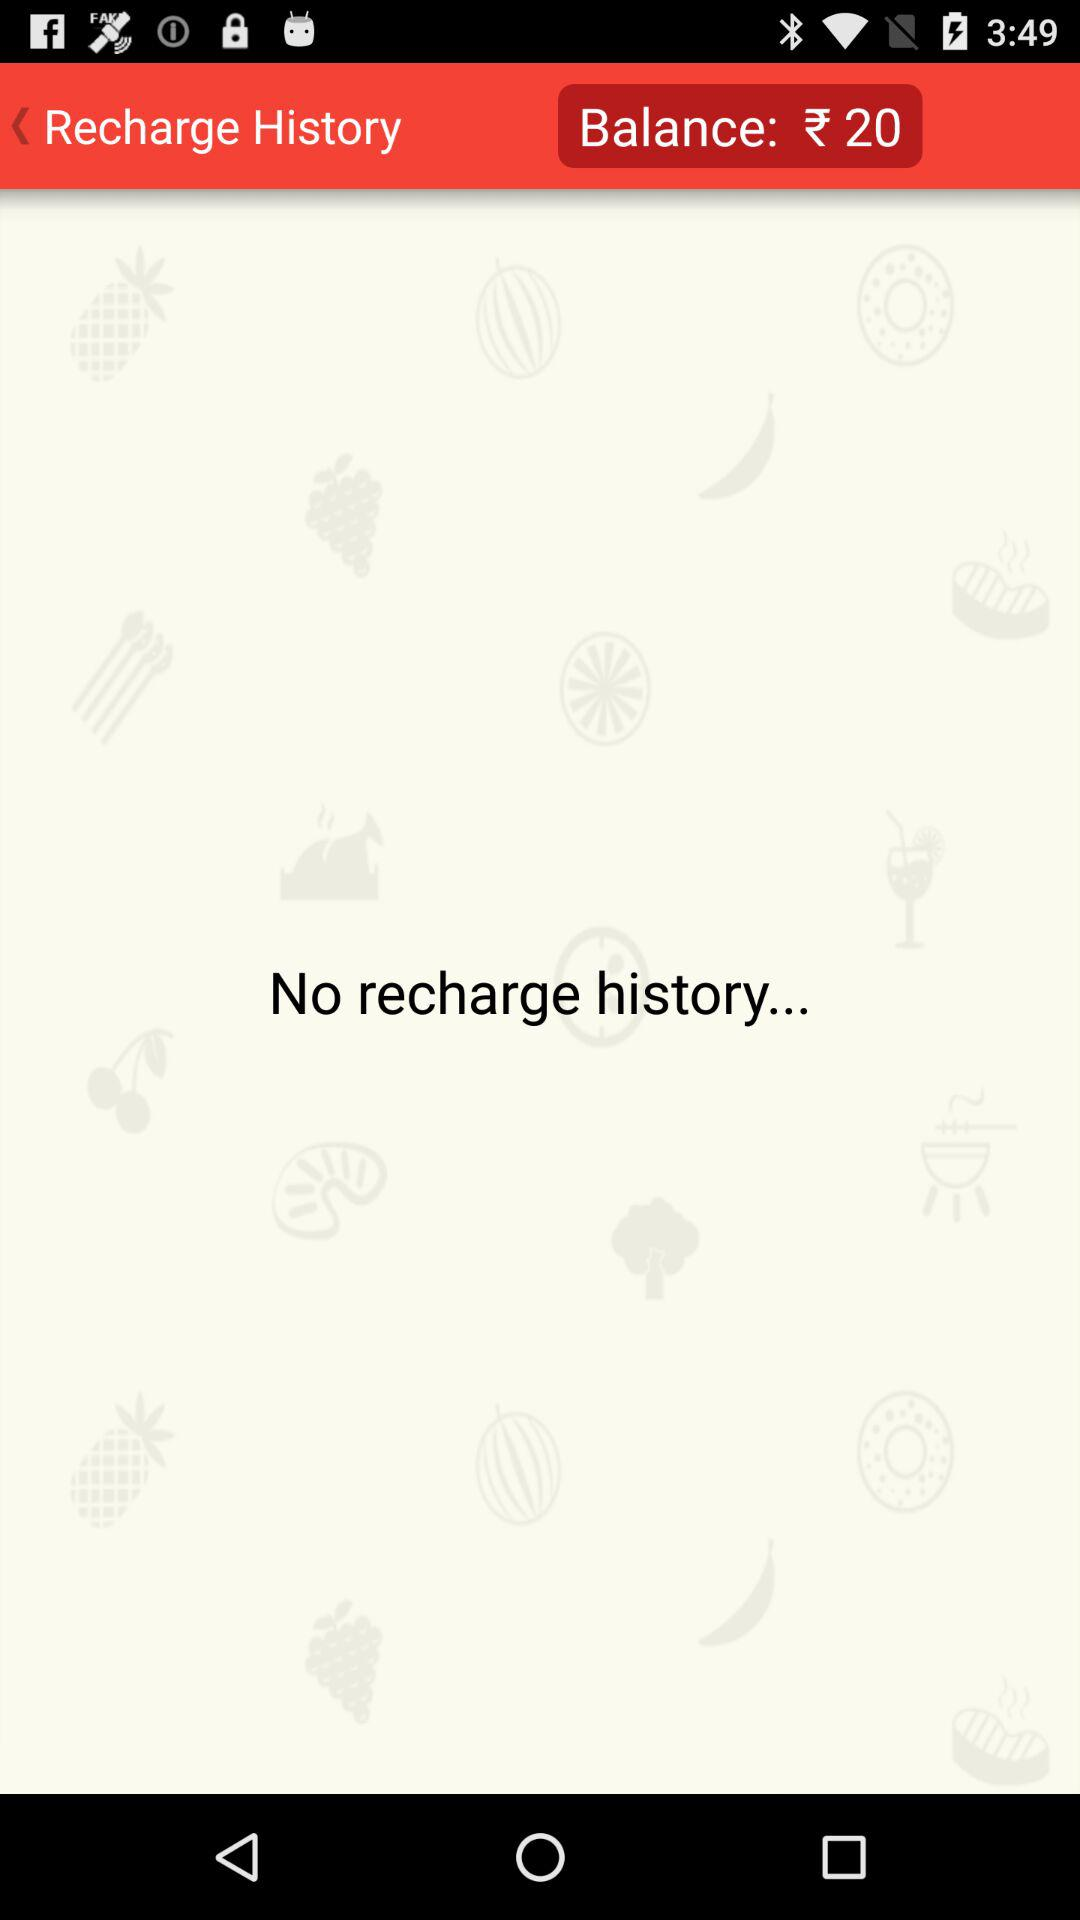How many recharge history entries are there?
Answer the question using a single word or phrase. 0 